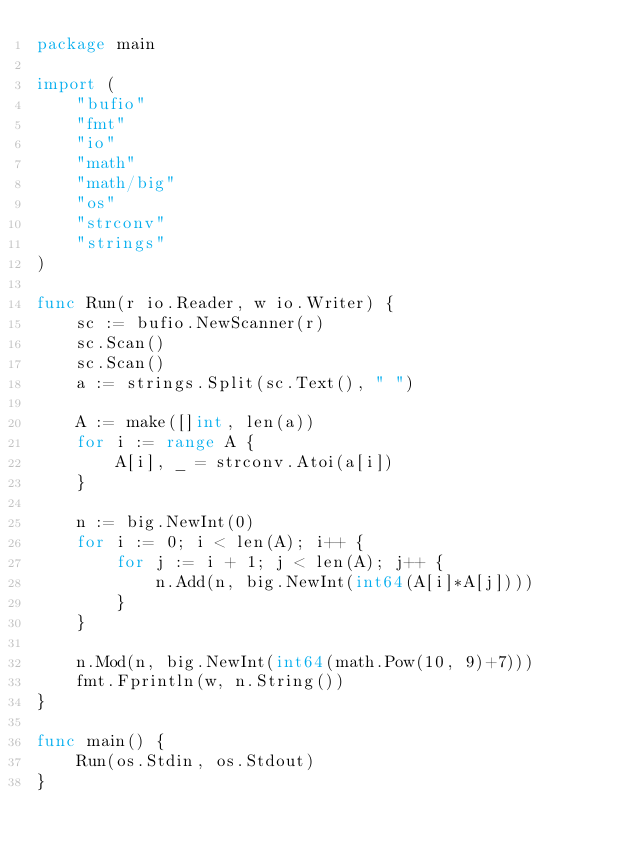<code> <loc_0><loc_0><loc_500><loc_500><_Go_>package main

import (
	"bufio"
	"fmt"
	"io"
	"math"
	"math/big"
	"os"
	"strconv"
	"strings"
)

func Run(r io.Reader, w io.Writer) {
	sc := bufio.NewScanner(r)
	sc.Scan()
	sc.Scan()
	a := strings.Split(sc.Text(), " ")

	A := make([]int, len(a))
	for i := range A {
		A[i], _ = strconv.Atoi(a[i])
	}

	n := big.NewInt(0)
	for i := 0; i < len(A); i++ {
		for j := i + 1; j < len(A); j++ {
			n.Add(n, big.NewInt(int64(A[i]*A[j])))
		}
	}

	n.Mod(n, big.NewInt(int64(math.Pow(10, 9)+7)))
	fmt.Fprintln(w, n.String())
}

func main() {
	Run(os.Stdin, os.Stdout)
}
</code> 